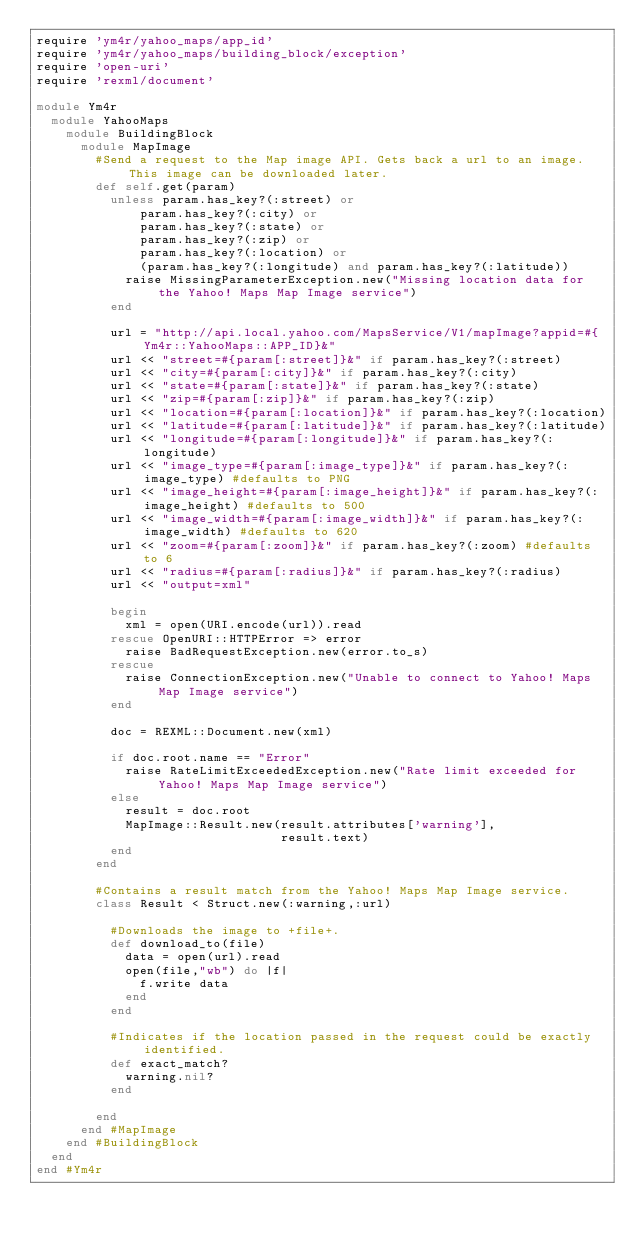Convert code to text. <code><loc_0><loc_0><loc_500><loc_500><_Ruby_>require 'ym4r/yahoo_maps/app_id'
require 'ym4r/yahoo_maps/building_block/exception'
require 'open-uri'
require 'rexml/document'

module Ym4r
  module YahooMaps
    module BuildingBlock
      module MapImage
        #Send a request to the Map image API. Gets back a url to an image. This image can be downloaded later.
        def self.get(param)
          unless param.has_key?(:street) or
              param.has_key?(:city) or
              param.has_key?(:state) or
              param.has_key?(:zip) or
              param.has_key?(:location) or
              (param.has_key?(:longitude) and param.has_key?(:latitude))
            raise MissingParameterException.new("Missing location data for the Yahoo! Maps Map Image service")
          end
          
          url = "http://api.local.yahoo.com/MapsService/V1/mapImage?appid=#{Ym4r::YahooMaps::APP_ID}&"
          url << "street=#{param[:street]}&" if param.has_key?(:street)
          url << "city=#{param[:city]}&" if param.has_key?(:city)
          url << "state=#{param[:state]}&" if param.has_key?(:state)
          url << "zip=#{param[:zip]}&" if param.has_key?(:zip)
          url << "location=#{param[:location]}&" if param.has_key?(:location)
          url << "latitude=#{param[:latitude]}&" if param.has_key?(:latitude)
          url << "longitude=#{param[:longitude]}&" if param.has_key?(:longitude)
          url << "image_type=#{param[:image_type]}&" if param.has_key?(:image_type) #defaults to PNG
          url << "image_height=#{param[:image_height]}&" if param.has_key?(:image_height) #defaults to 500
          url << "image_width=#{param[:image_width]}&" if param.has_key?(:image_width) #defaults to 620
          url << "zoom=#{param[:zoom]}&" if param.has_key?(:zoom) #defaults to 6
          url << "radius=#{param[:radius]}&" if param.has_key?(:radius)
          url << "output=xml"
          
          begin
            xml = open(URI.encode(url)).read
          rescue OpenURI::HTTPError => error
            raise BadRequestException.new(error.to_s)
          rescue
            raise ConnectionException.new("Unable to connect to Yahoo! Maps Map Image service")
          end
          
          doc = REXML::Document.new(xml) 
          
          if doc.root.name == "Error"
            raise RateLimitExceededException.new("Rate limit exceeded for Yahoo! Maps Map Image service")
          else
            result = doc.root
            MapImage::Result.new(result.attributes['warning'],
                                 result.text)
          end
        end
        
        #Contains a result match from the Yahoo! Maps Map Image service. 
        class Result < Struct.new(:warning,:url)
          
          #Downloads the image to +file+.
          def download_to(file)
            data = open(url).read
            open(file,"wb") do |f|
              f.write data
            end
          end
          
          #Indicates if the location passed in the request could be exactly identified.
          def exact_match?
            warning.nil?
          end
          
        end
      end #MapImage
    end #BuildingBlock
  end
end #Ym4r
</code> 